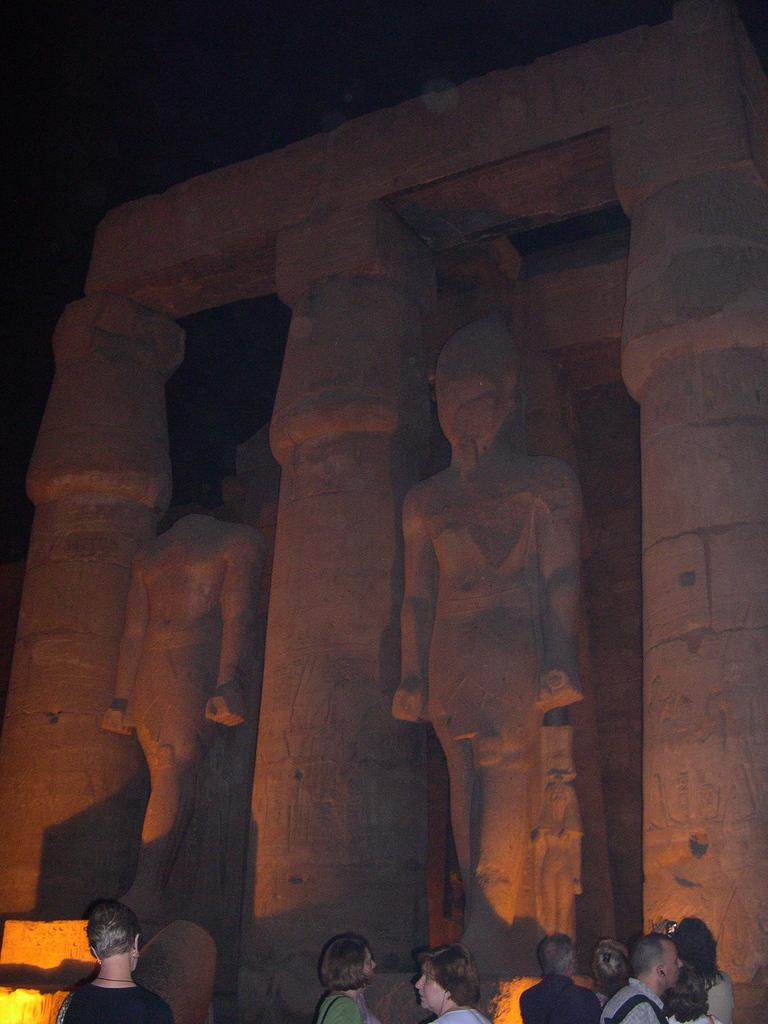What can be seen in the image? There is a group of people in the image. How are the people dressed? The people are wearing different color dresses. What is in front of the group? There are statues of people in front of the group. What is the color of the background in the background? The background of the image is black. What type of government is depicted in the image? There is no indication of a government in the image. The image only shows a group of people, statues, and different color dresses. 